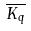Convert formula to latex. <formula><loc_0><loc_0><loc_500><loc_500>\overline { K _ { q } }</formula> 